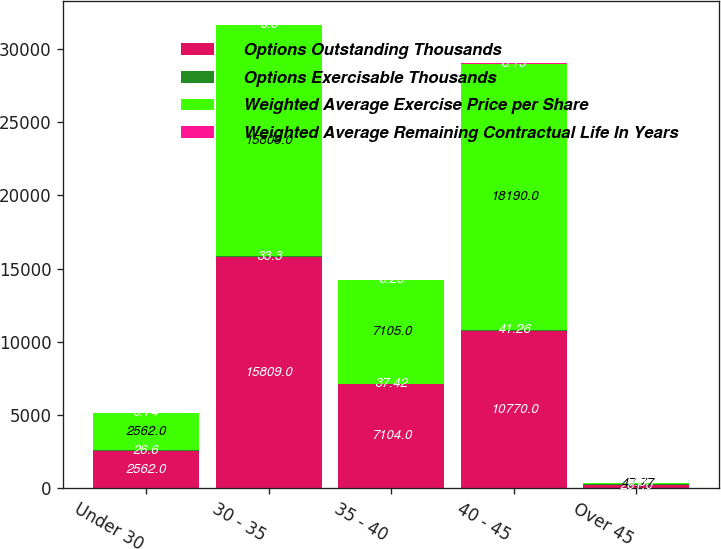<chart> <loc_0><loc_0><loc_500><loc_500><stacked_bar_chart><ecel><fcel>Under 30<fcel>30 - 35<fcel>35 - 40<fcel>40 - 45<fcel>Over 45<nl><fcel>Options Outstanding Thousands<fcel>2562<fcel>15809<fcel>7104<fcel>10770<fcel>261<nl><fcel>Options Exercisable Thousands<fcel>26.6<fcel>33.3<fcel>37.42<fcel>41.26<fcel>47.77<nl><fcel>Weighted Average Exercise Price per Share<fcel>2562<fcel>15809<fcel>7105<fcel>18190<fcel>47.77<nl><fcel>Weighted Average Remaining Contractual Life In Years<fcel>0.74<fcel>3.6<fcel>3.25<fcel>6.19<fcel>7.8<nl></chart> 